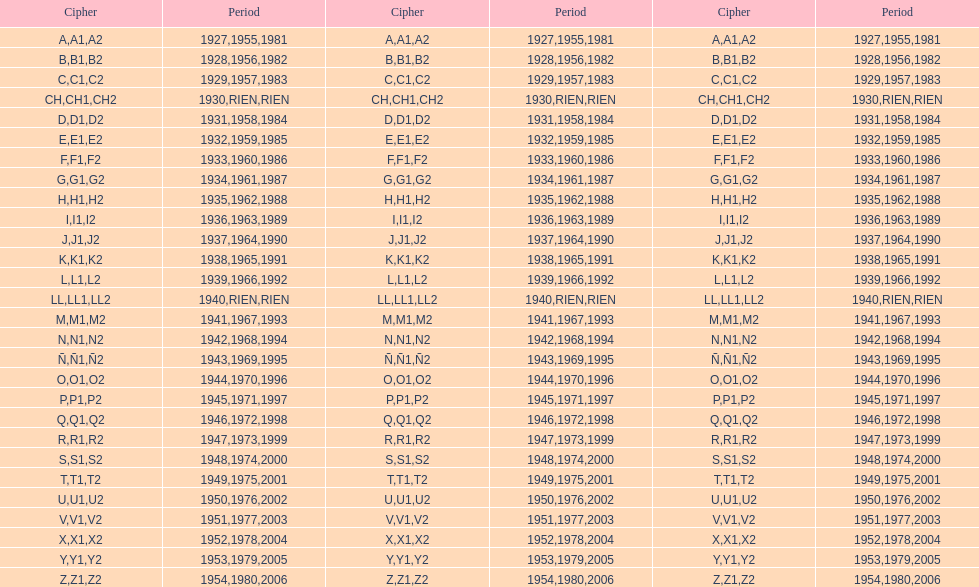List every code not linked with a year. CH1, CH2, LL1, LL2. 